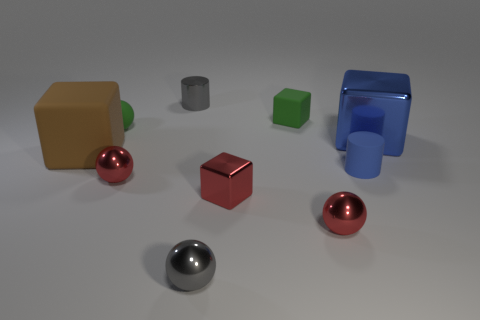Subtract all small gray spheres. How many spheres are left? 3 Subtract all green cubes. How many red balls are left? 2 Subtract all blue cubes. How many cubes are left? 3 Subtract 3 spheres. How many spheres are left? 1 Subtract all balls. How many objects are left? 6 Subtract 2 red balls. How many objects are left? 8 Subtract all red blocks. Subtract all blue cylinders. How many blocks are left? 3 Subtract all shiny things. Subtract all big yellow metallic cylinders. How many objects are left? 4 Add 3 small red blocks. How many small red blocks are left? 4 Add 6 large blue objects. How many large blue objects exist? 7 